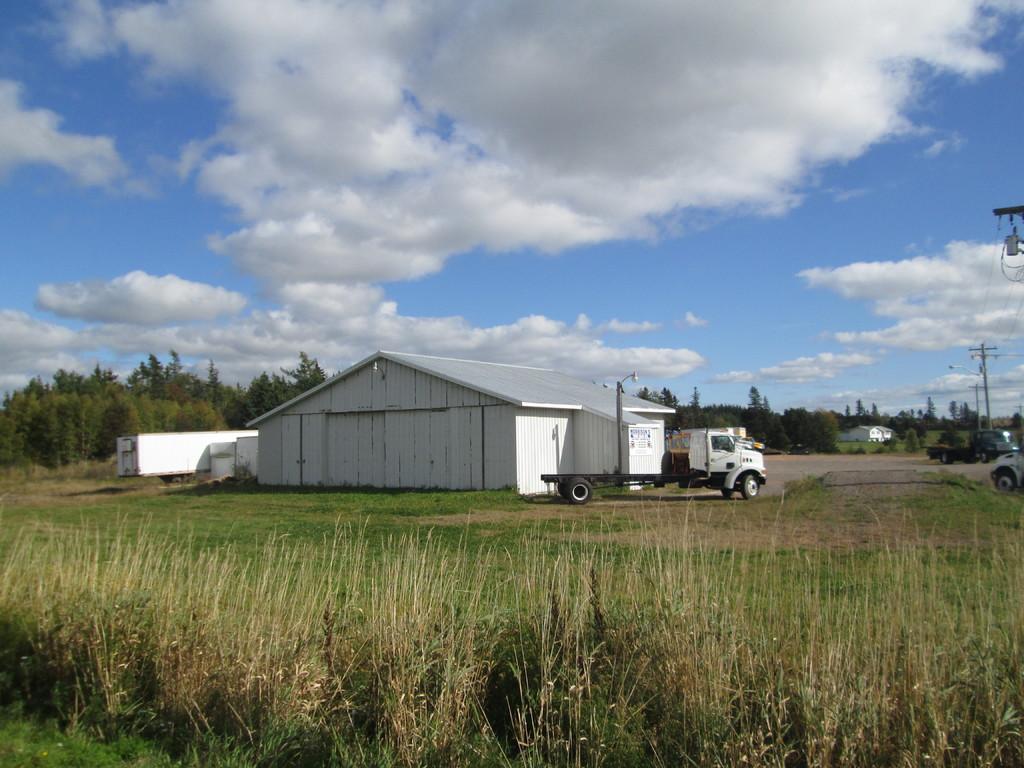Describe this image in one or two sentences. In this picture we can see small white shed house and beside a white color van. Behind there are some trees and in the front side we can see the grass. 